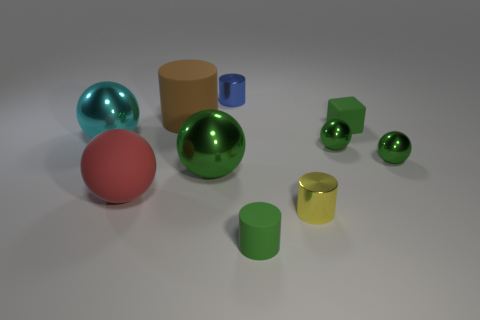There is a tiny cylinder that is the same color as the block; what is its material?
Your answer should be very brief. Rubber. What material is the large brown object?
Provide a succinct answer. Rubber. Does the tiny blue thing have the same material as the red thing?
Offer a very short reply. No. What material is the large ball in front of the green metal sphere on the left side of the small green cylinder made of?
Provide a short and direct response. Rubber. The metallic ball that is both on the left side of the blue cylinder and right of the large cyan sphere is what color?
Provide a succinct answer. Green. Are there more big matte spheres that are to the right of the tiny green cylinder than big brown rubber things to the left of the small blue metallic cylinder?
Offer a very short reply. No. There is a cylinder that is behind the brown matte cylinder; does it have the same size as the big cyan metal object?
Your answer should be compact. No. There is a small green matte thing behind the small matte object that is in front of the block; how many big cyan metal spheres are in front of it?
Offer a very short reply. 1. There is a rubber thing that is both left of the large green ball and in front of the brown matte cylinder; what is its size?
Provide a succinct answer. Large. What number of other things are the same shape as the brown rubber thing?
Offer a terse response. 3. 